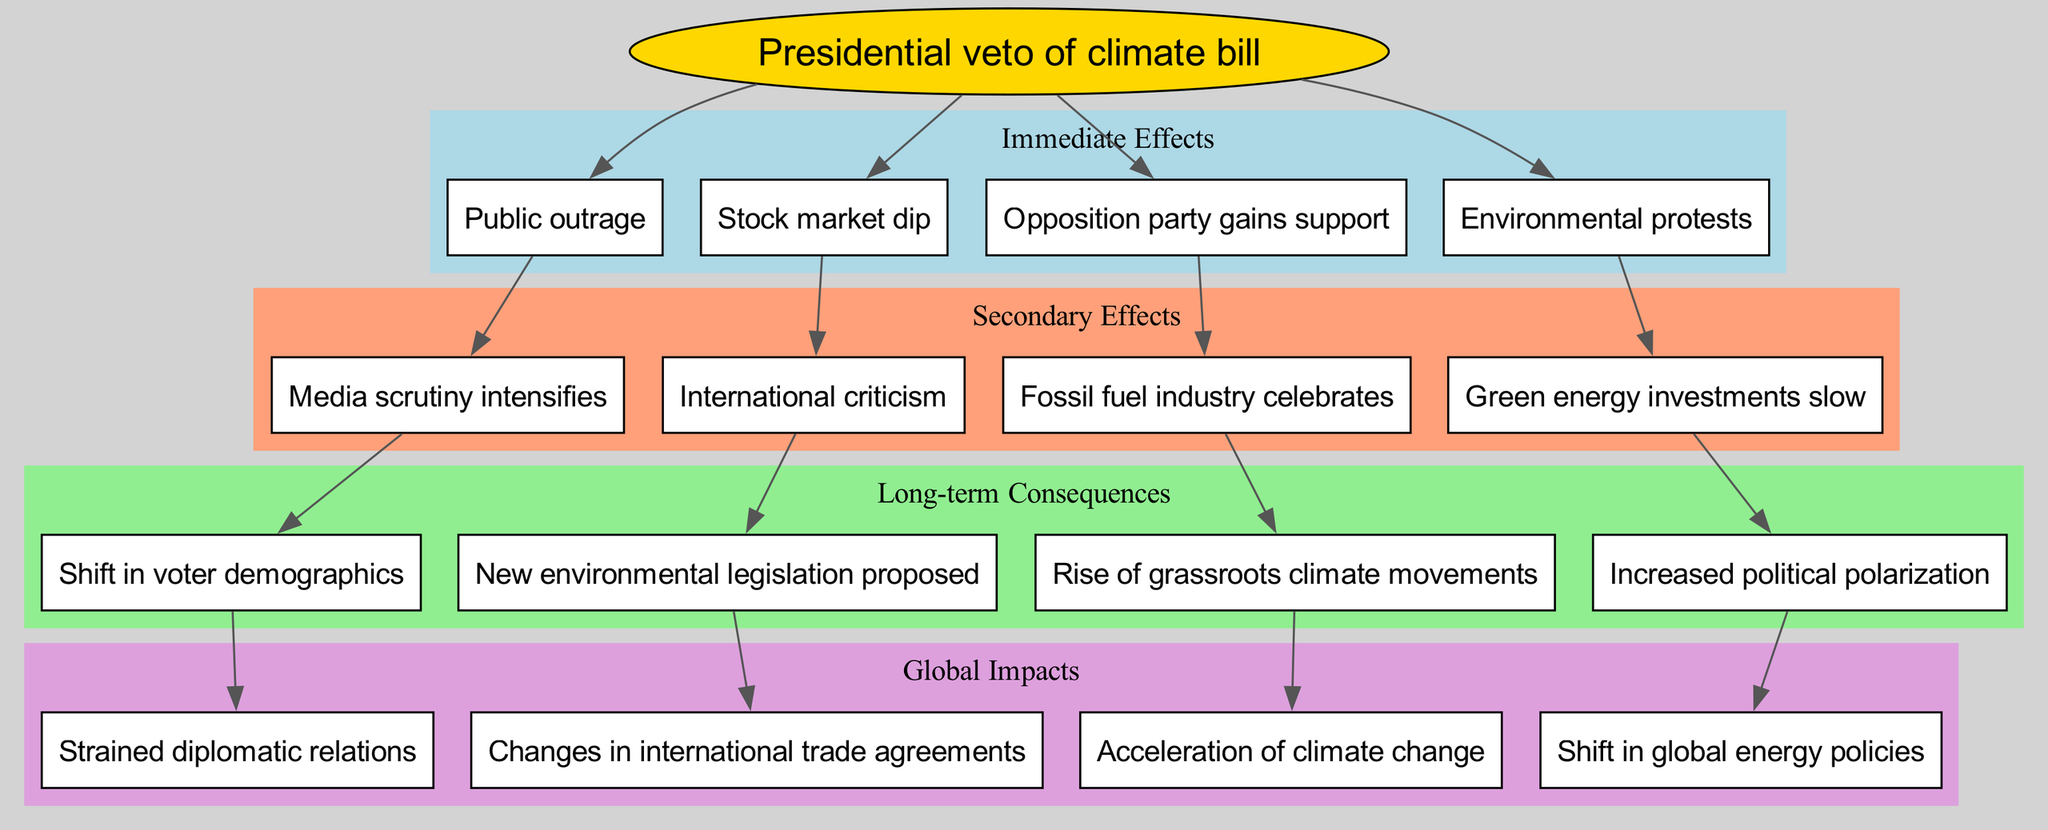What is the central event in the diagram? The central event is explicitly stated in the diagram. It is the starting point from which all other effects are derived. The diagram labels this event, making it easy to identify.
Answer: Presidential veto of climate bill How many immediate effects are there? By counting the number of immediate effects listed in the corresponding section of the diagram, the total can be determined. The immediate effects are clearly grouped and labeled in the diagram.
Answer: 4 What is one of the secondary effects resulting from the immediate effects? The secondary effects branch from the immediate effects mentioned in the diagram. By identifying the connections, it can be seen that each immediate effect leads to at least one secondary effect.
Answer: Media scrutiny intensifies Which immediate effect leads to the secondary effect of 'International criticism'? To determine this, one must trace the connections in the diagram from the immediate effects to the specific secondary effect in question. By following the lines of influence, the correct immediate effect can be pinpointed.
Answer: Environmental protests What is the last node connected to 'Rise of grassroots climate movements'? The last node can be found by examining the connections stemming from 'Rise of grassroots climate movements' in the long-term consequences section. Identifying its predecessor in the flow of the diagram provides the answer.
Answer: Increased political polarization How many long-term consequences are there? The diagram groups the long-term consequences and labels them accordingly. By counting the nodes in this section, the total number of long-term consequences can be easily identified.
Answer: 4 Which global impact results from the long-term consequence of 'Shift in voter demographics'? To find this, one must trace the arrow that extends from 'Shift in voter demographics' to the global impacts section. Each long-term consequence is connected to a specific global impact.
Answer: Strained diplomatic relations Which immediate effect has the most direct consequences in the diagram? Evaluating the immediate effects and observing where they lead can indicate which one has multiple subsequent effects. The connections will reveal the most impactful immediate effect.
Answer: Public outrage What color is used to represent secondary effects in the diagram? The diagram employs distinct colors to differentiate between the various sections. By identifying the color associated with the secondary effects, the answer can be found.
Answer: Lightsalmon 